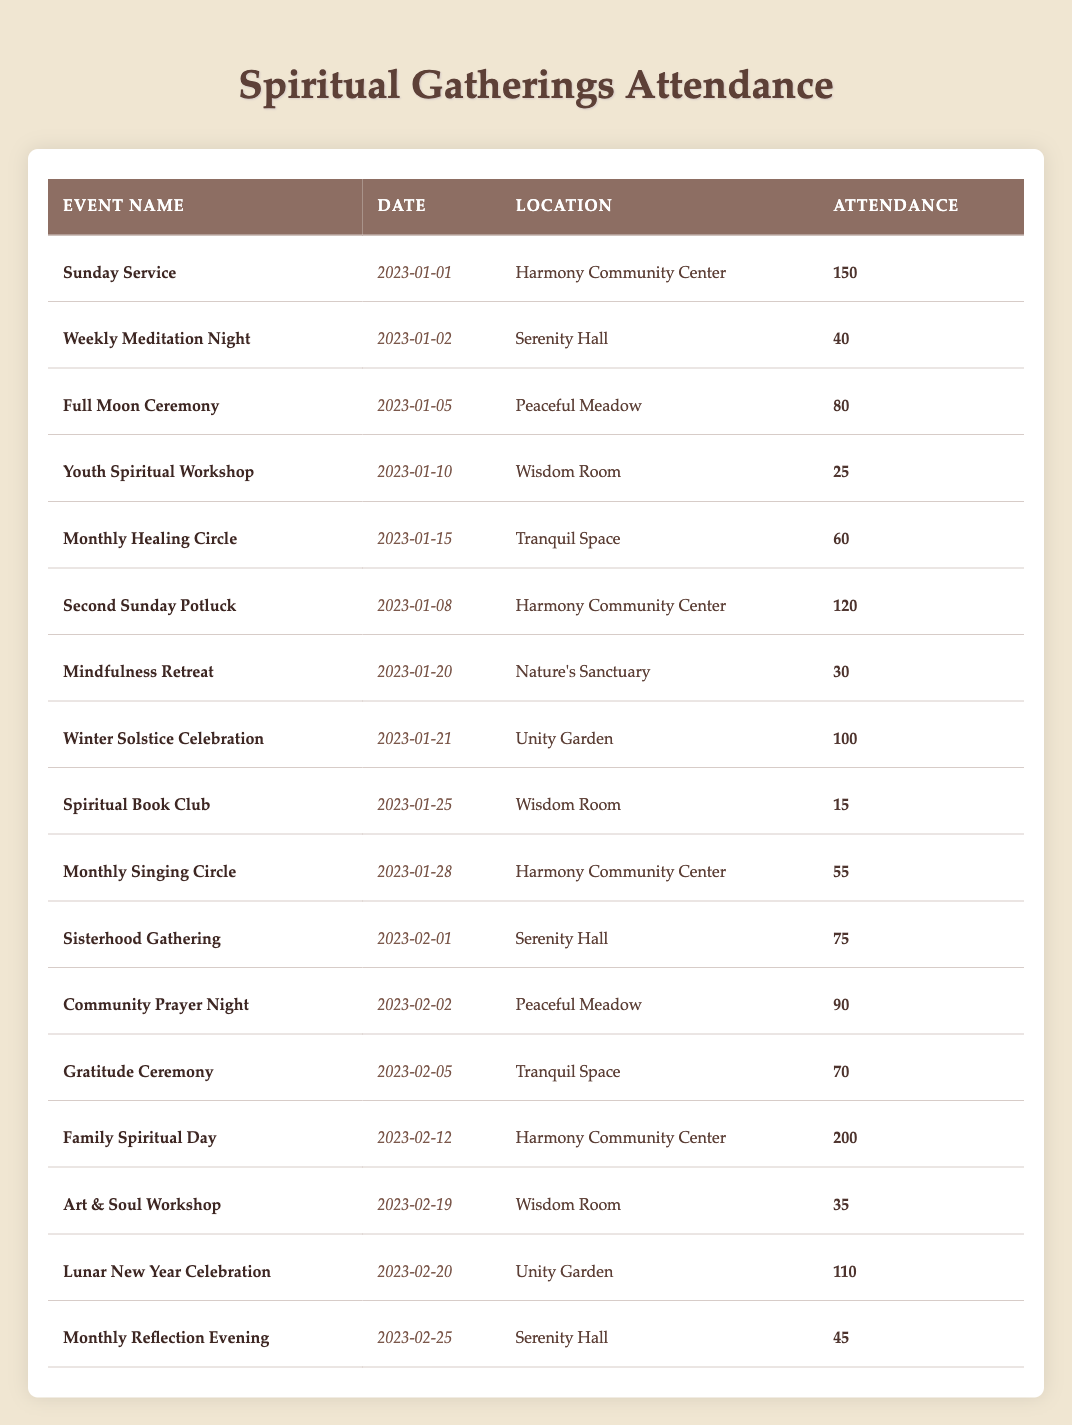What was the attendance at the Sunday Service? The table shows that on January 1, 2023, the Sunday Service had an attendance of 150 people.
Answer: 150 How many events were held in January 2023? By checking the table, there are 10 events listed in January 2023, including Sunday Service, Weekly Meditation Night, and others leading up to the end of the month.
Answer: 10 Which event had the highest attendance in February 2023? The Family Spiritual Day on February 12, 2023, had the highest attendance with 200 participants, making it the most attended event for that month.
Answer: Family Spiritual Day What is the average attendance for the Full Moon Ceremony and Winter Solstice Celebration? The attendance for the Full Moon Ceremony is 80 and for the Winter Solstice Celebration is 100. The average is calculated as (80 + 100) / 2 = 90.
Answer: 90 Was the attendance for the Monthly Singing Circle greater than 50? The table indicates that the Monthly Singing Circle had an attendance of 55, which is indeed greater than 50.
Answer: Yes How many people attended the events at the Harmony Community Center in January? The events at the Harmony Community Center in January are Sunday Service (150), Second Sunday Potluck (120), and Monthly Singing Circle (55). Adding these gives 150 + 120 + 55 = 325.
Answer: 325 What was the total attendance for the Spiritual Book Club and Youth Spiritual Workshop? The Spiritual Book Club had an attendance of 15, and the Youth Spiritual Workshop had 25. Summing these values gives 15 + 25 = 40.
Answer: 40 Compare the attendance of the Sisterhood Gathering and the Community Prayer Night. Was one significantly more attended than the other? Sisterhood Gathering had 75 attendees, while Community Prayer Night had 90 attendees. The difference is 90 - 75 = 15, indicating that Community Prayer Night was more attended.
Answer: Yes Which location hosted the most events in January 2023? By reviewing the locations of the January events, the Harmony Community Center hosted 3 events: Sunday Service, Second Sunday Potluck, and Monthly Singing Circle, the most of any location.
Answer: Harmony Community Center Calculate the total attendance for all events held at Serenity Hall. The events held at Serenity Hall are Weekly Meditation Night (40), Sisterhood Gathering (75), and Monthly Reflection Evening (45). The total attendance is calculated as 40 + 75 + 45 = 160.
Answer: 160 